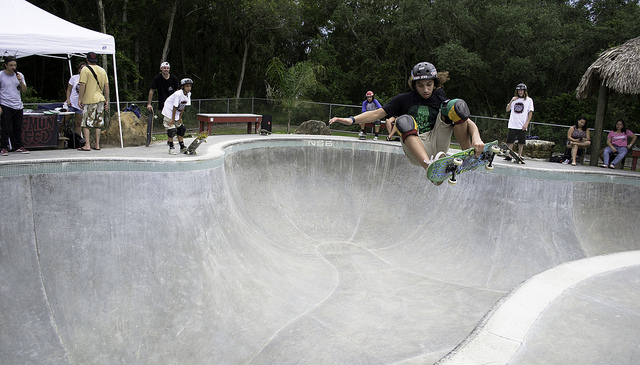Read all the text in this image. MUN EED 